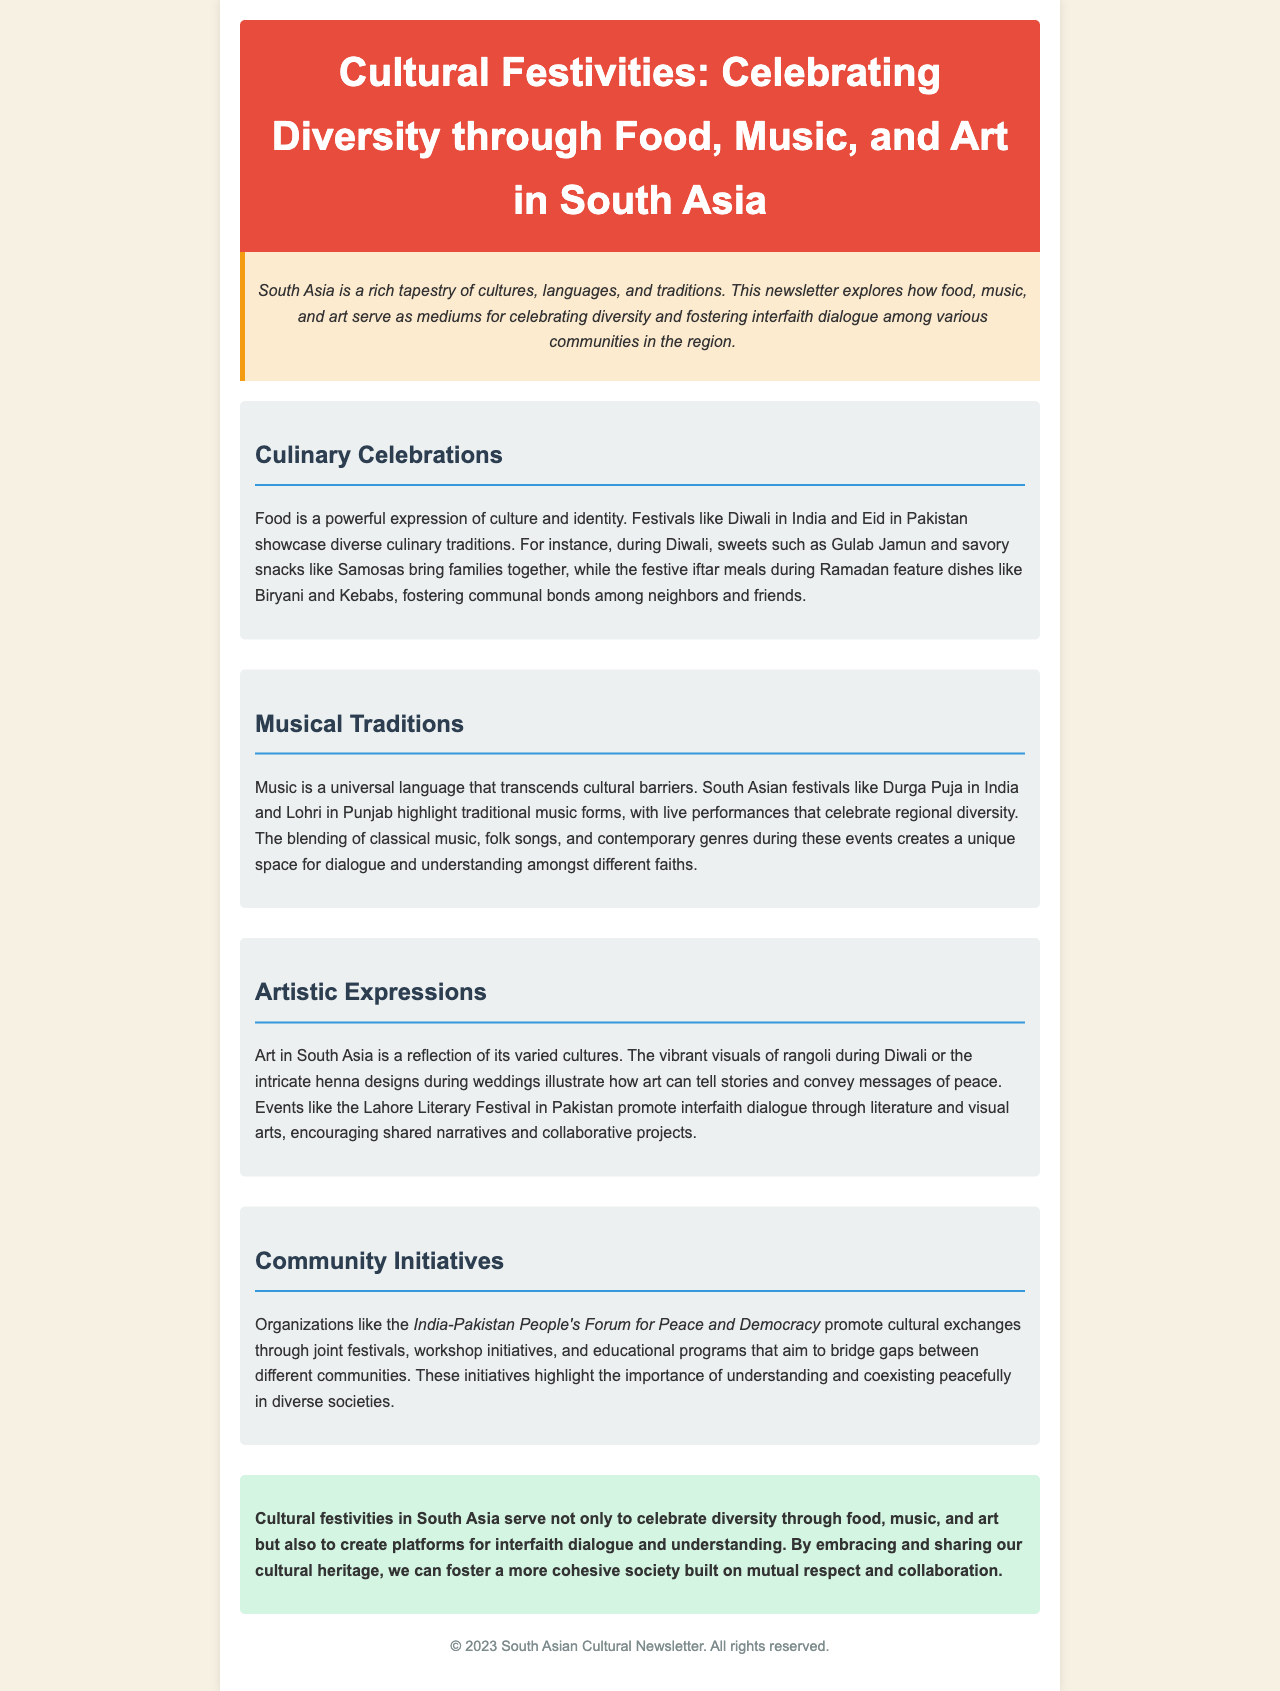What are two desserts mentioned during Diwali? The desserts mentioned during Diwali are Gulab Jamun, indicating cultural significance through sweets.
Answer: Gulab Jamun Which musical festival is highlighted in the document? The document refers specifically to Durga Puja in India, emphasizing traditional music.
Answer: Durga Puja What is a key initiative mentioned for promoting interfaith dialogue? The key initiative mentioned is the India-Pakistan People's Forum for Peace and Democracy, as a bridge between communities.
Answer: India-Pakistan People's Forum for Peace and Democracy What type of art is illustrated during weddings? The document illustrates intricate henna designs as a significant art form during weddings.
Answer: Henna designs Which event promotes interfaith dialogue through literature? The Lahore Literary Festival is mentioned as a significant event promoting dialogue through literature and visual arts.
Answer: Lahore Literary Festival During which festival do people enjoy iftar meals? The festival featuring iftar meals is Ramadan, which fosters communal bonds through shared meals.
Answer: Ramadan How does art in South Asia convey messages? The document explains that art, such as rangoli, tells stories and conveys messages of peace, reflecting cultural narratives.
Answer: Peace What is a vibrant visual activity during Diwali? Rangoli is the vibrant visual activity during Diwali that reflects cultural richness through colorful art.
Answer: Rangoli 